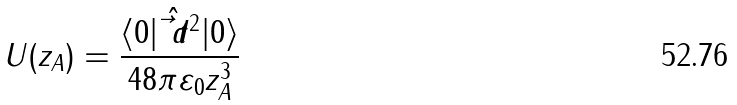Convert formula to latex. <formula><loc_0><loc_0><loc_500><loc_500>U ( z _ { A } ) = \frac { \langle 0 | \hat { \vec { t } { d } } ^ { 2 } | 0 \rangle } { 4 8 \pi \varepsilon _ { 0 } z _ { A } ^ { 3 } }</formula> 